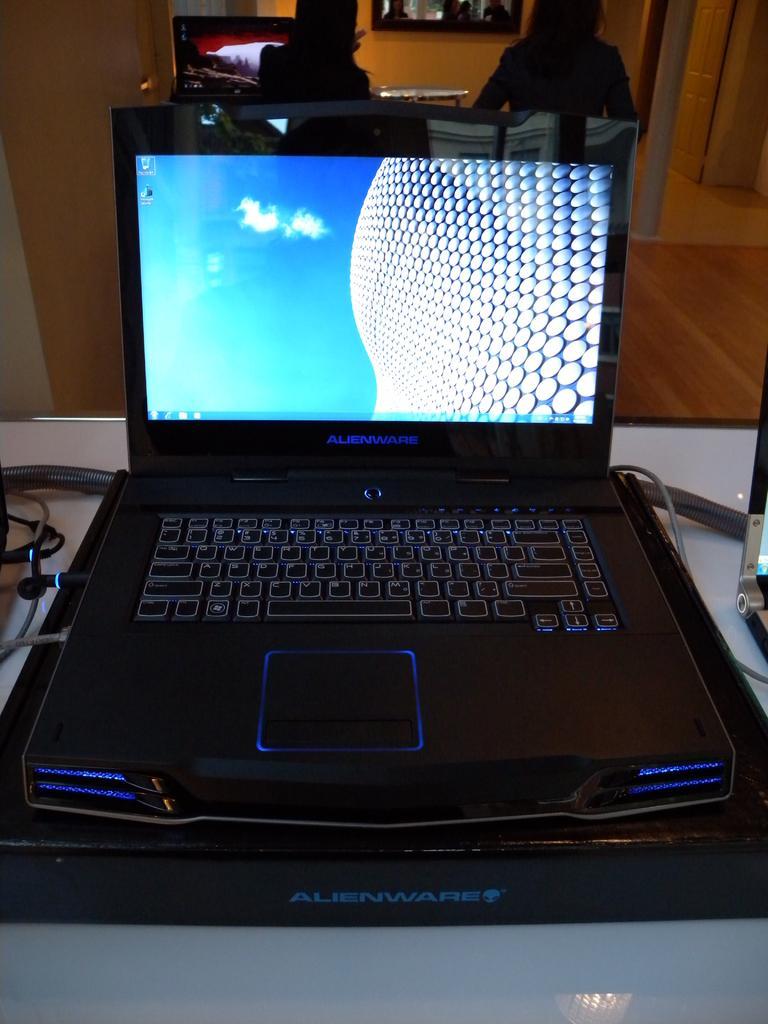<image>
Write a terse but informative summary of the picture. A laptop is open and resting on a black box labelled "Alienware." 